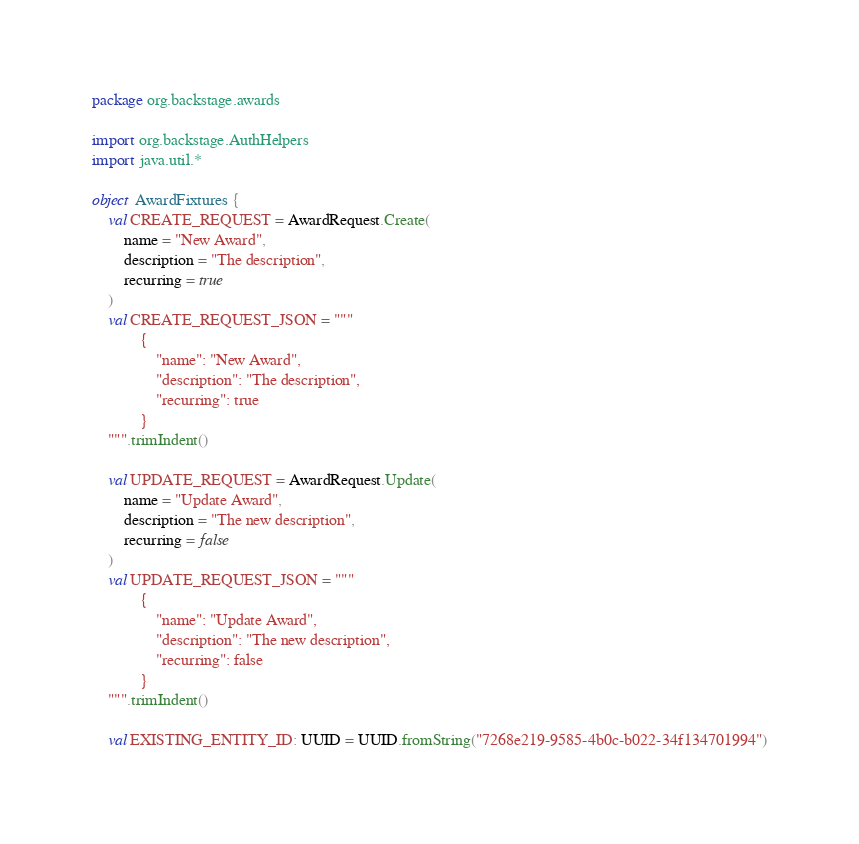<code> <loc_0><loc_0><loc_500><loc_500><_Kotlin_>package org.backstage.awards

import org.backstage.AuthHelpers
import java.util.*

object AwardFixtures {
    val CREATE_REQUEST = AwardRequest.Create(
        name = "New Award",
        description = "The description",
        recurring = true
    )
    val CREATE_REQUEST_JSON = """
            {
                "name": "New Award",
                "description": "The description",
                "recurring": true
            }
    """.trimIndent()

    val UPDATE_REQUEST = AwardRequest.Update(
        name = "Update Award",
        description = "The new description",
        recurring = false
    )
    val UPDATE_REQUEST_JSON = """
            {
                "name": "Update Award",
                "description": "The new description",
                "recurring": false
            }
    """.trimIndent()

    val EXISTING_ENTITY_ID: UUID = UUID.fromString("7268e219-9585-4b0c-b022-34f134701994")</code> 